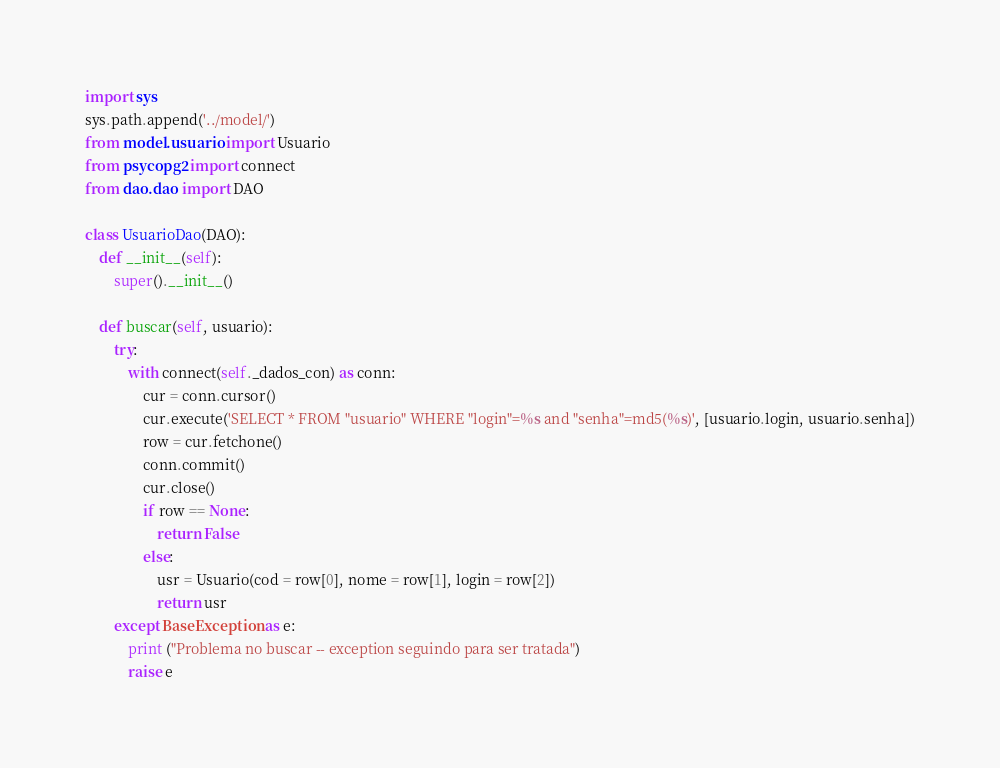<code> <loc_0><loc_0><loc_500><loc_500><_Python_>import sys
sys.path.append('../model/')
from model.usuario import Usuario
from psycopg2 import connect
from dao.dao import DAO

class UsuarioDao(DAO):
    def __init__(self):
        super().__init__()
    
    def buscar(self, usuario):
        try:
            with connect(self._dados_con) as conn:
                cur = conn.cursor()
                cur.execute('SELECT * FROM "usuario" WHERE "login"=%s and "senha"=md5(%s)', [usuario.login, usuario.senha])
                row = cur.fetchone()
                conn.commit()
                cur.close()
                if row == None:
                    return False
                else:
                    usr = Usuario(cod = row[0], nome = row[1], login = row[2])
                    return usr
        except BaseException as e:
            print ("Problema no buscar -- exception seguindo para ser tratada")
            raise e </code> 